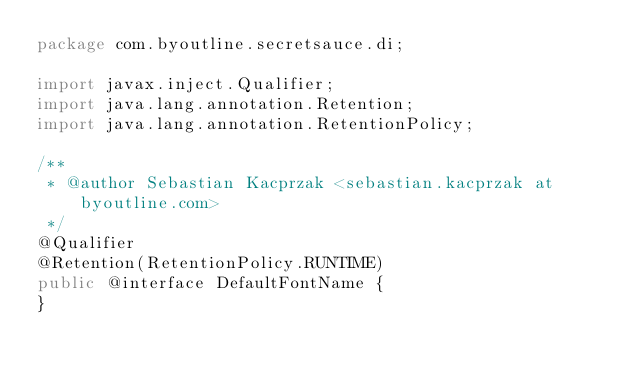Convert code to text. <code><loc_0><loc_0><loc_500><loc_500><_Java_>package com.byoutline.secretsauce.di;

import javax.inject.Qualifier;
import java.lang.annotation.Retention;
import java.lang.annotation.RetentionPolicy;

/**
 * @author Sebastian Kacprzak <sebastian.kacprzak at byoutline.com>
 */
@Qualifier
@Retention(RetentionPolicy.RUNTIME)
public @interface DefaultFontName {
}
</code> 